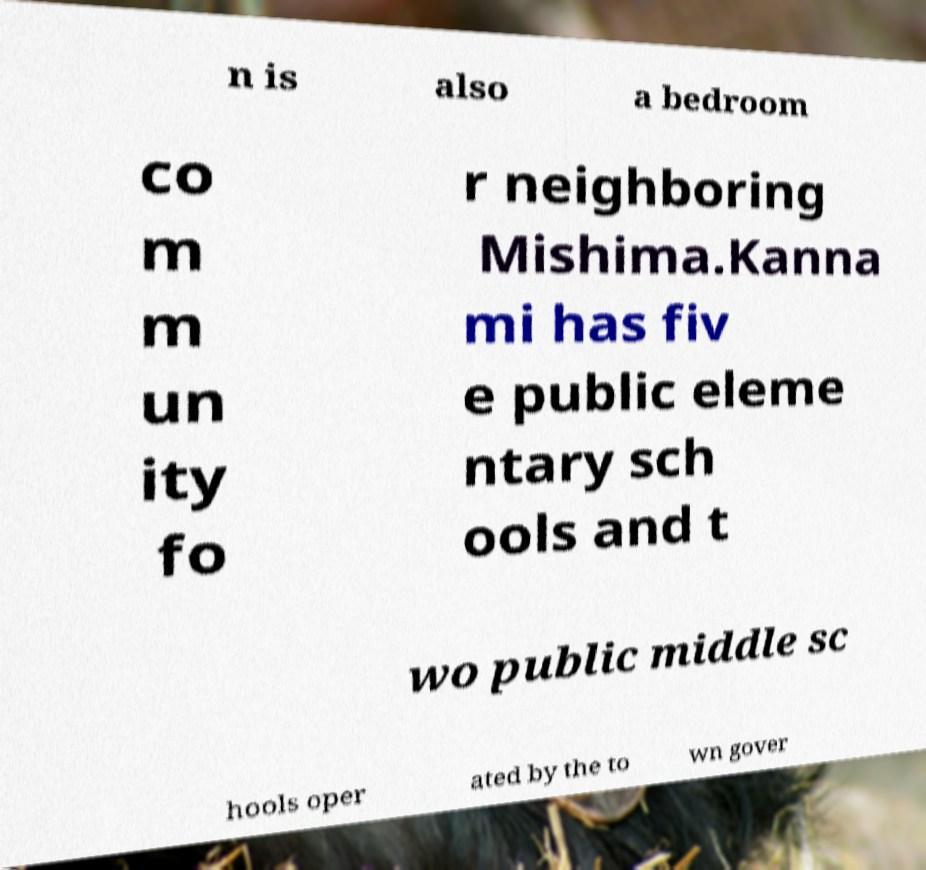Can you accurately transcribe the text from the provided image for me? n is also a bedroom co m m un ity fo r neighboring Mishima.Kanna mi has fiv e public eleme ntary sch ools and t wo public middle sc hools oper ated by the to wn gover 